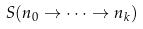<formula> <loc_0><loc_0><loc_500><loc_500>S ( n _ { 0 } \to \cdots \to n _ { k } )</formula> 